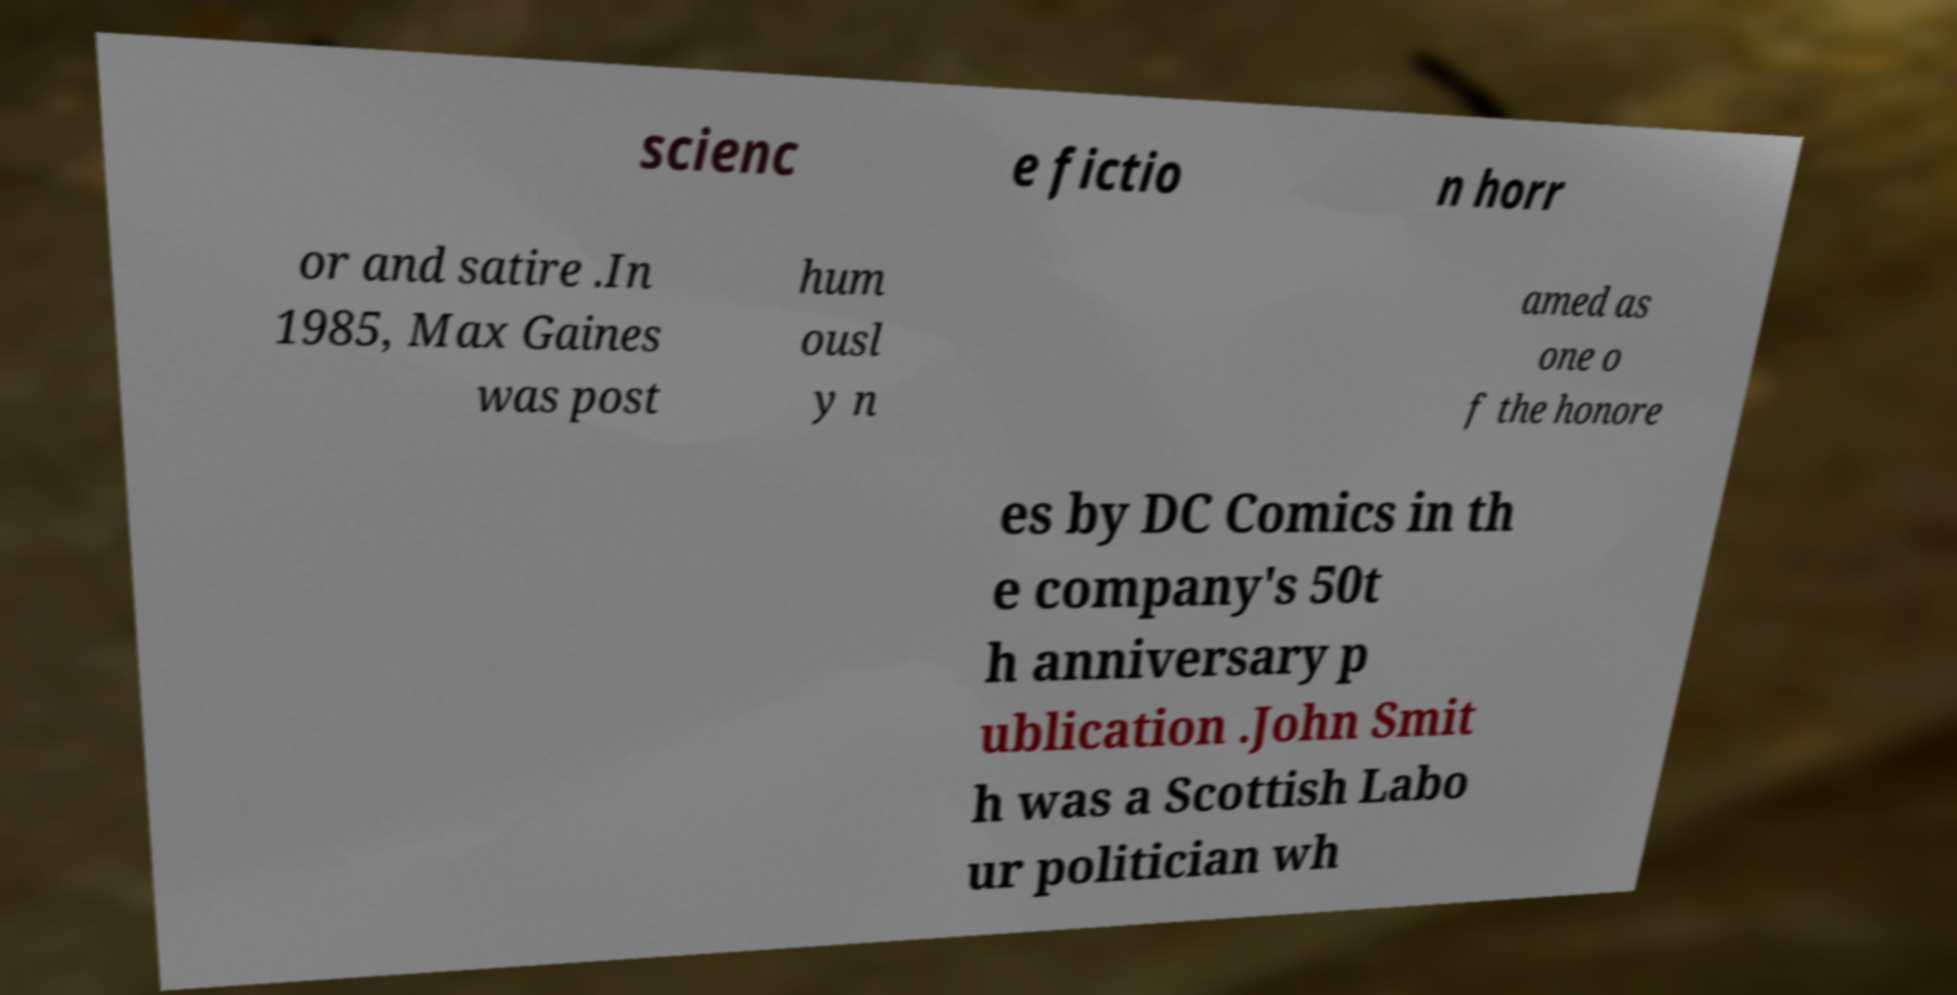Please read and relay the text visible in this image. What does it say? scienc e fictio n horr or and satire .In 1985, Max Gaines was post hum ousl y n amed as one o f the honore es by DC Comics in th e company's 50t h anniversary p ublication .John Smit h was a Scottish Labo ur politician wh 